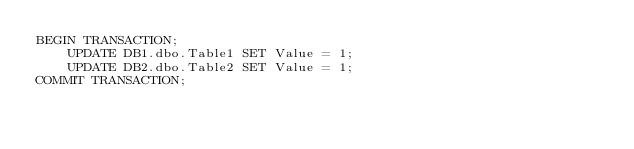Convert code to text. <code><loc_0><loc_0><loc_500><loc_500><_SQL_>BEGIN TRANSACTION;
    UPDATE DB1.dbo.Table1 SET Value = 1;
    UPDATE DB2.dbo.Table2 SET Value = 1;
COMMIT TRANSACTION;</code> 